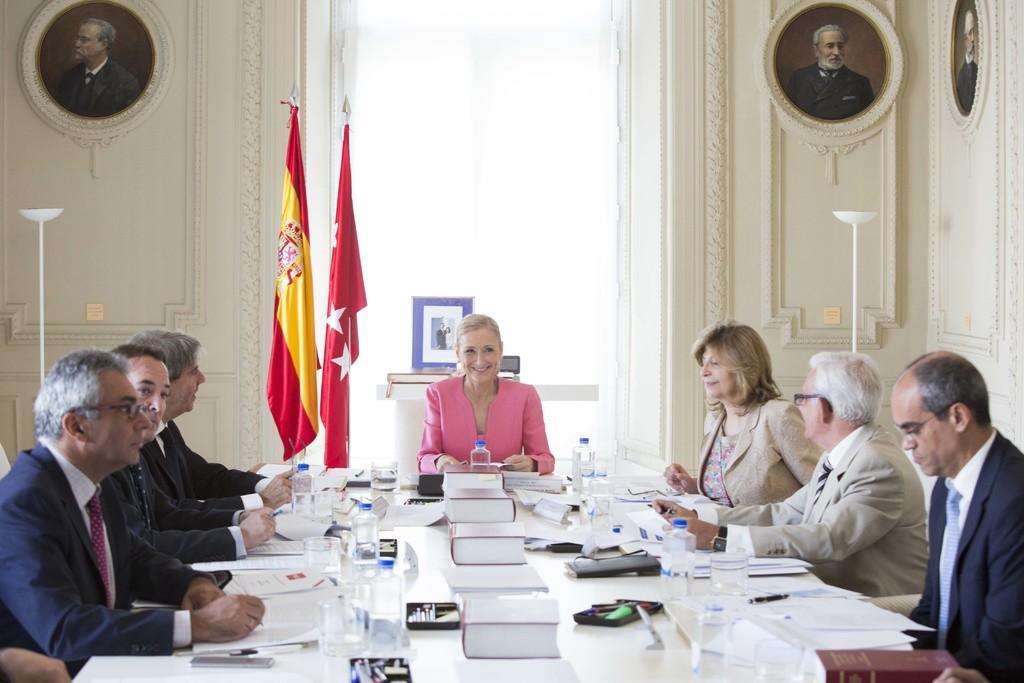How would you summarize this image in a sentence or two? In this image I can see a group of people are sitting on a chair in front of a table on the table I can see glass bottles, books and other objects on it. I can also see there are few flags. 